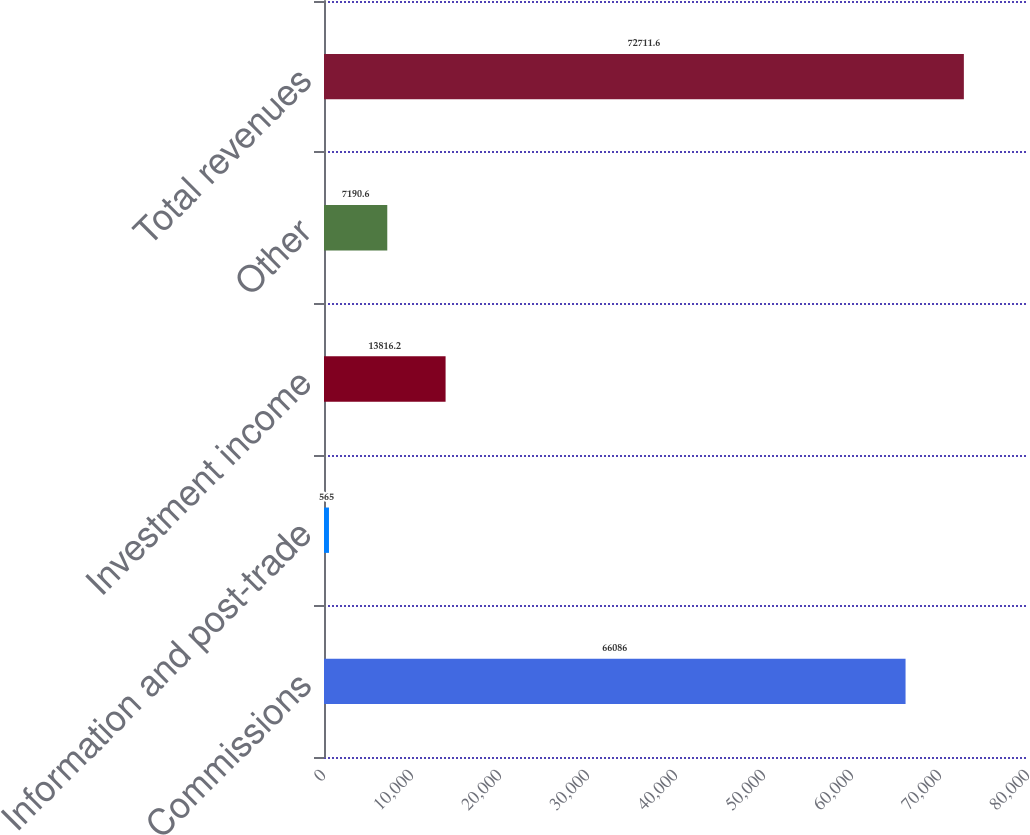Convert chart to OTSL. <chart><loc_0><loc_0><loc_500><loc_500><bar_chart><fcel>Commissions<fcel>Information and post-trade<fcel>Investment income<fcel>Other<fcel>Total revenues<nl><fcel>66086<fcel>565<fcel>13816.2<fcel>7190.6<fcel>72711.6<nl></chart> 